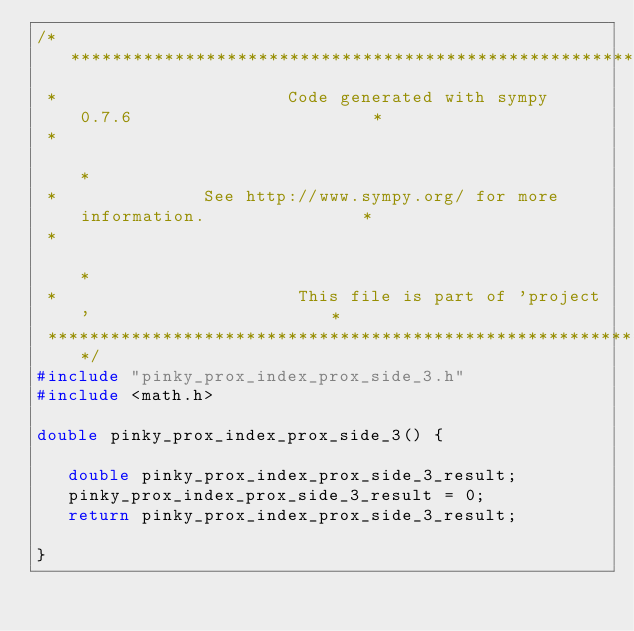Convert code to text. <code><loc_0><loc_0><loc_500><loc_500><_C_>/******************************************************************************
 *                      Code generated with sympy 0.7.6                       *
 *                                                                            *
 *              See http://www.sympy.org/ for more information.               *
 *                                                                            *
 *                       This file is part of 'project'                       *
 ******************************************************************************/
#include "pinky_prox_index_prox_side_3.h"
#include <math.h>

double pinky_prox_index_prox_side_3() {

   double pinky_prox_index_prox_side_3_result;
   pinky_prox_index_prox_side_3_result = 0;
   return pinky_prox_index_prox_side_3_result;

}
</code> 